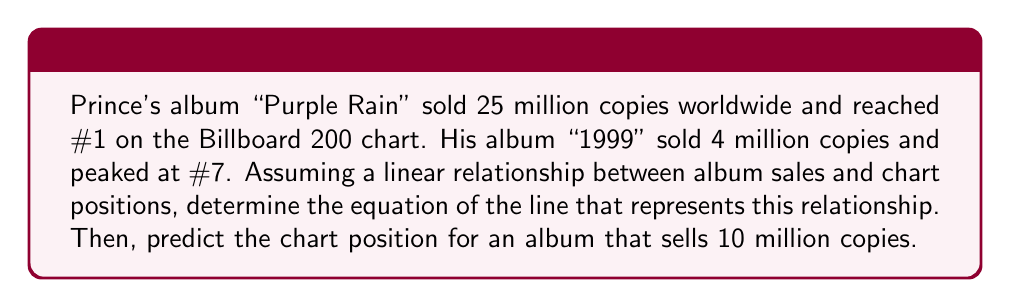Provide a solution to this math problem. Let's approach this step-by-step:

1) We have two data points:
   (25, 1) for "Purple Rain"
   (4, 7) for "1999"

2) The slope-intercept form of a line is $y = mx + b$, where $m$ is the slope and $b$ is the y-intercept.

3) Calculate the slope:
   $m = \frac{y_2 - y_1}{x_2 - x_1} = \frac{7 - 1}{4 - 25} = \frac{6}{-21} = -\frac{2}{7}$

4) Use the point-slope form with (25, 1):
   $y - 1 = -\frac{2}{7}(x - 25)$

5) Simplify to slope-intercept form:
   $y = -\frac{2}{7}x + \frac{50}{7} + 1$
   $y = -\frac{2}{7}x + \frac{57}{7}$

6) This is our equation: $y = -\frac{2}{7}x + \frac{57}{7}$

7) To predict the chart position for 10 million copies:
   $y = -\frac{2}{7}(10) + \frac{57}{7}$
   $y = -\frac{20}{7} + \frac{57}{7} = \frac{37}{7} \approx 5.29$

8) Since chart positions are whole numbers, we round to the nearest integer: 5
Answer: $y = -\frac{2}{7}x + \frac{57}{7}$; Chart position for 10 million copies: 5 